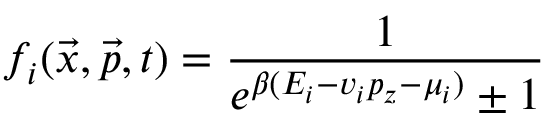<formula> <loc_0><loc_0><loc_500><loc_500>f _ { i } ( \vec { x } , \vec { p } , t ) = \frac { 1 } { e ^ { \beta ( E _ { i } - v _ { i } p _ { z } - \mu _ { i } ) } \pm 1 }</formula> 